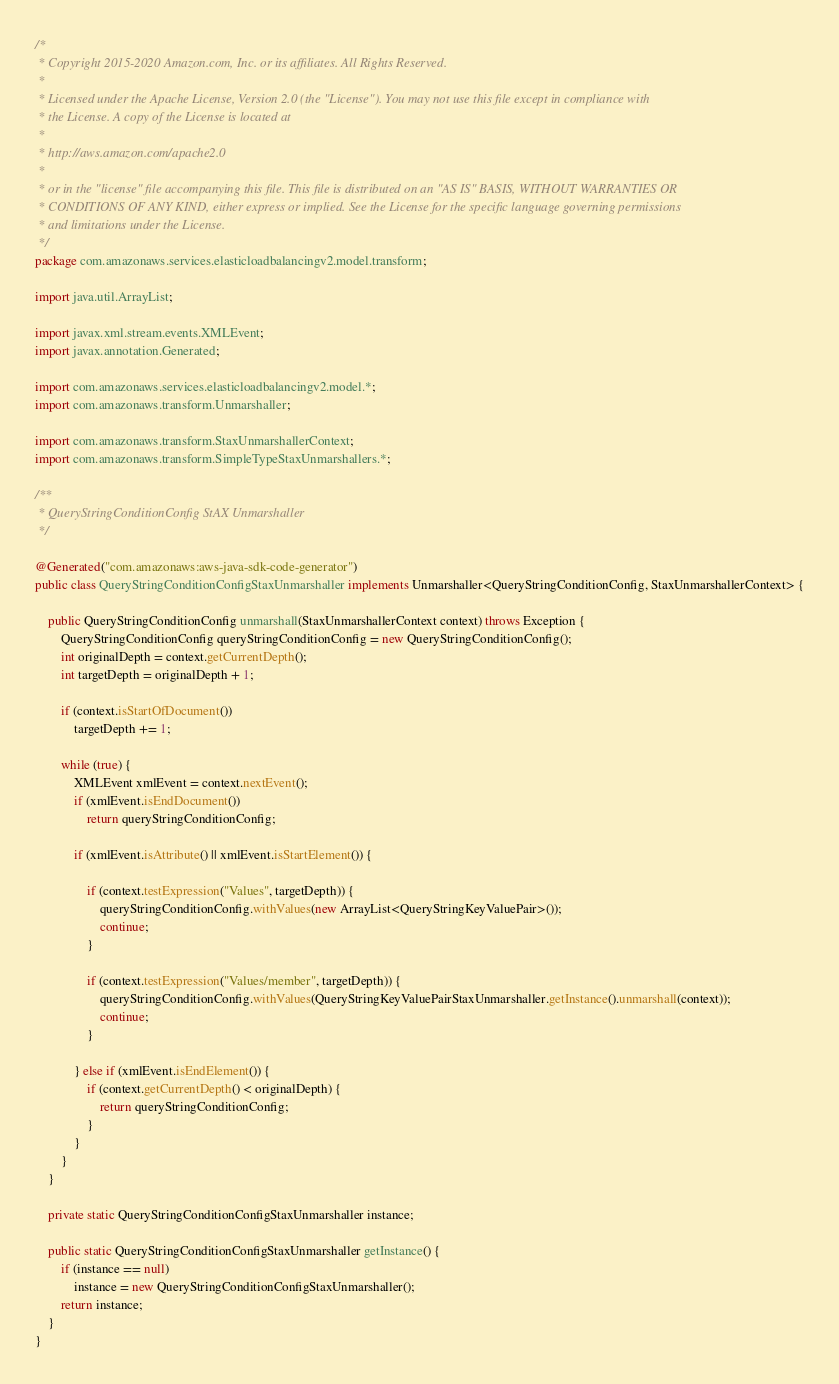Convert code to text. <code><loc_0><loc_0><loc_500><loc_500><_Java_>/*
 * Copyright 2015-2020 Amazon.com, Inc. or its affiliates. All Rights Reserved.
 * 
 * Licensed under the Apache License, Version 2.0 (the "License"). You may not use this file except in compliance with
 * the License. A copy of the License is located at
 * 
 * http://aws.amazon.com/apache2.0
 * 
 * or in the "license" file accompanying this file. This file is distributed on an "AS IS" BASIS, WITHOUT WARRANTIES OR
 * CONDITIONS OF ANY KIND, either express or implied. See the License for the specific language governing permissions
 * and limitations under the License.
 */
package com.amazonaws.services.elasticloadbalancingv2.model.transform;

import java.util.ArrayList;

import javax.xml.stream.events.XMLEvent;
import javax.annotation.Generated;

import com.amazonaws.services.elasticloadbalancingv2.model.*;
import com.amazonaws.transform.Unmarshaller;

import com.amazonaws.transform.StaxUnmarshallerContext;
import com.amazonaws.transform.SimpleTypeStaxUnmarshallers.*;

/**
 * QueryStringConditionConfig StAX Unmarshaller
 */

@Generated("com.amazonaws:aws-java-sdk-code-generator")
public class QueryStringConditionConfigStaxUnmarshaller implements Unmarshaller<QueryStringConditionConfig, StaxUnmarshallerContext> {

    public QueryStringConditionConfig unmarshall(StaxUnmarshallerContext context) throws Exception {
        QueryStringConditionConfig queryStringConditionConfig = new QueryStringConditionConfig();
        int originalDepth = context.getCurrentDepth();
        int targetDepth = originalDepth + 1;

        if (context.isStartOfDocument())
            targetDepth += 1;

        while (true) {
            XMLEvent xmlEvent = context.nextEvent();
            if (xmlEvent.isEndDocument())
                return queryStringConditionConfig;

            if (xmlEvent.isAttribute() || xmlEvent.isStartElement()) {

                if (context.testExpression("Values", targetDepth)) {
                    queryStringConditionConfig.withValues(new ArrayList<QueryStringKeyValuePair>());
                    continue;
                }

                if (context.testExpression("Values/member", targetDepth)) {
                    queryStringConditionConfig.withValues(QueryStringKeyValuePairStaxUnmarshaller.getInstance().unmarshall(context));
                    continue;
                }

            } else if (xmlEvent.isEndElement()) {
                if (context.getCurrentDepth() < originalDepth) {
                    return queryStringConditionConfig;
                }
            }
        }
    }

    private static QueryStringConditionConfigStaxUnmarshaller instance;

    public static QueryStringConditionConfigStaxUnmarshaller getInstance() {
        if (instance == null)
            instance = new QueryStringConditionConfigStaxUnmarshaller();
        return instance;
    }
}
</code> 